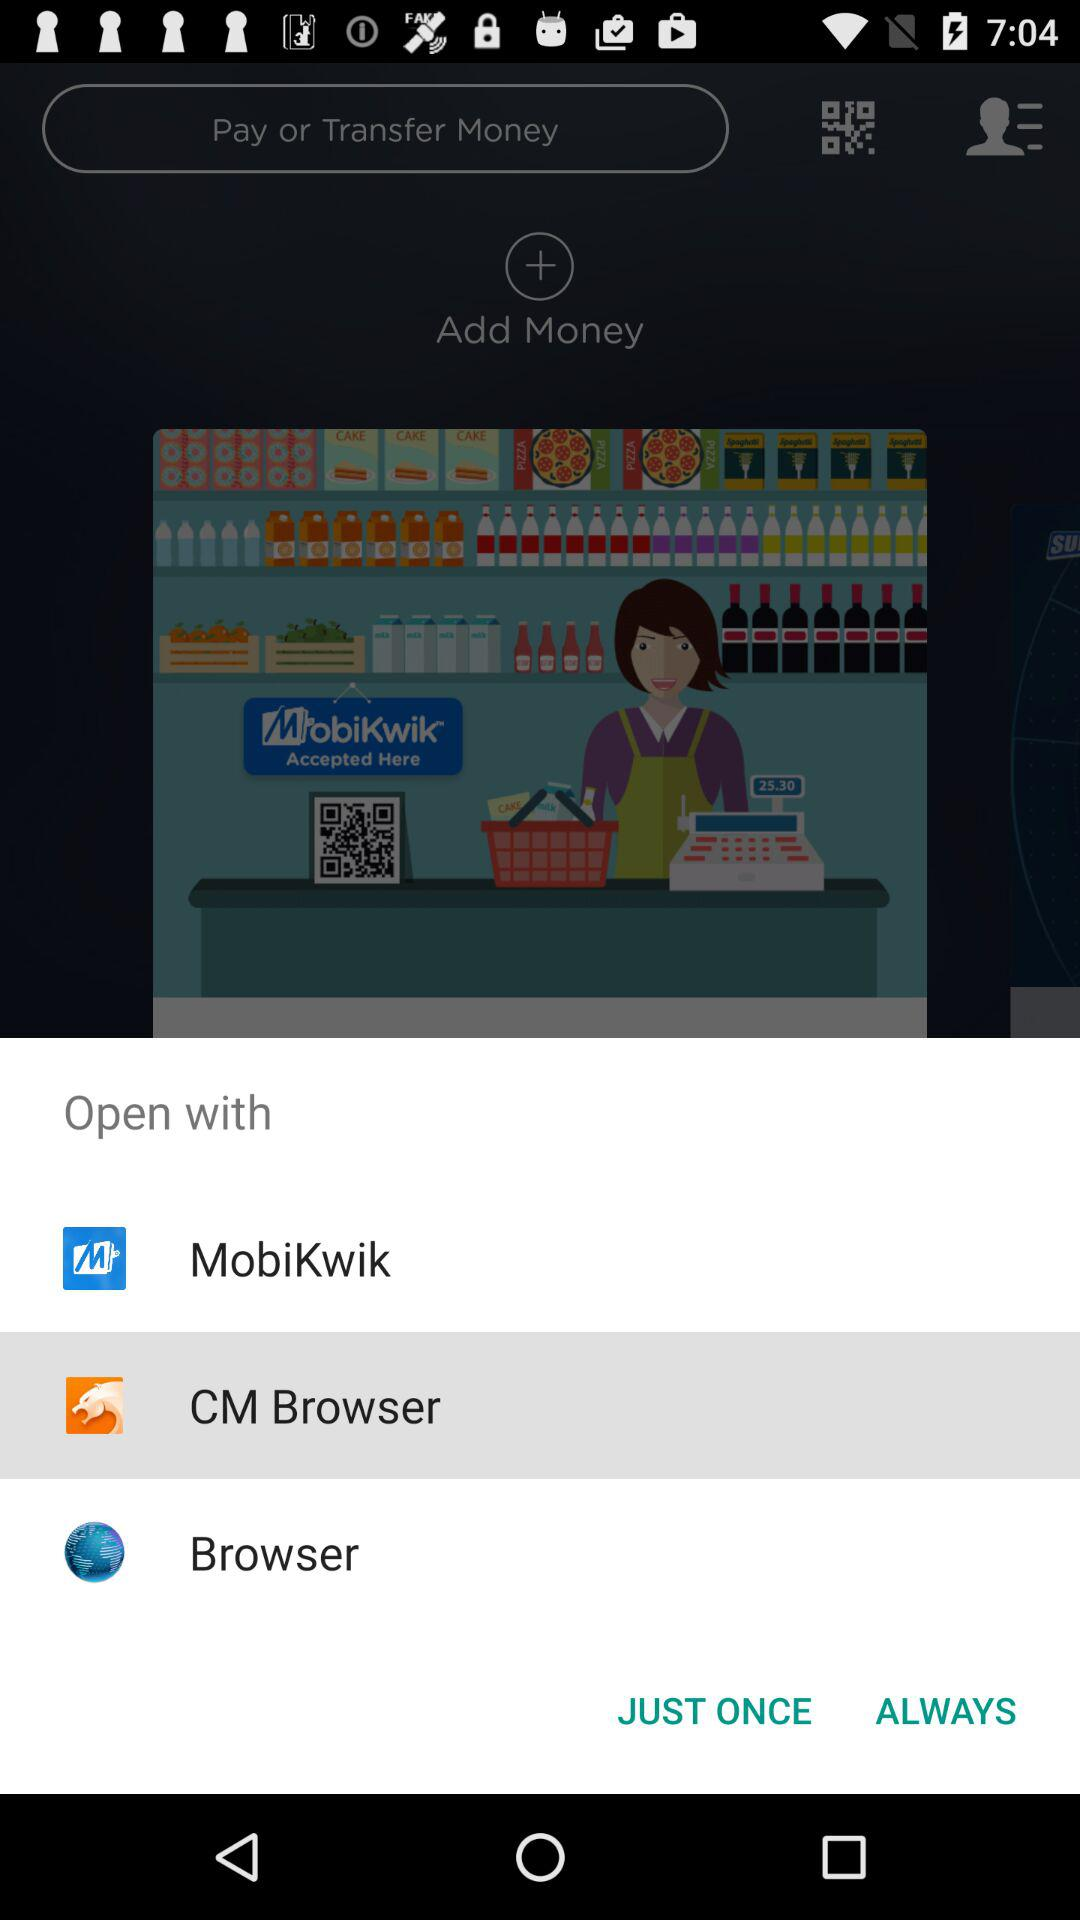What are the options available to open? The options available to open are : "MobiKwik", "CM Browser", and "Browser". 